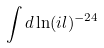Convert formula to latex. <formula><loc_0><loc_0><loc_500><loc_500>\int d \ln ( i l ) ^ { - 2 4 }</formula> 